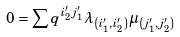Convert formula to latex. <formula><loc_0><loc_0><loc_500><loc_500>0 = \sum q ^ { i _ { 2 } ^ { \prime } j _ { 1 } ^ { \prime } } \lambda _ { \left ( i _ { 1 } ^ { \prime } , i _ { 2 } ^ { \prime } \right ) } \mu _ { \left ( j _ { 1 } ^ { \prime } , j _ { 2 } ^ { \prime } \right ) }</formula> 